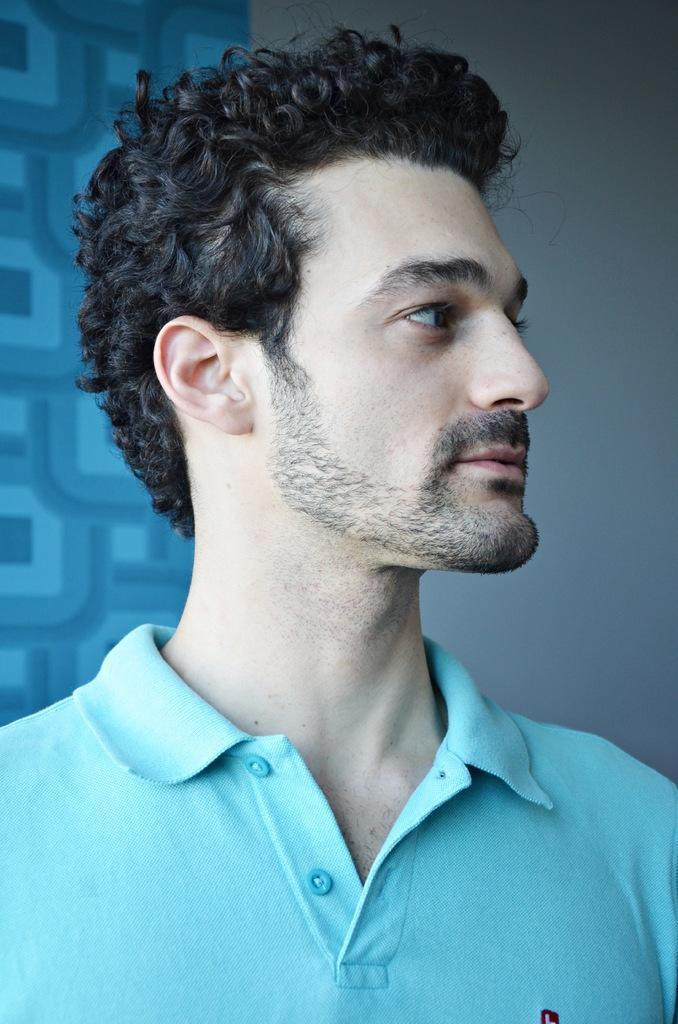Describe this image in one or two sentences. There is a man looking right side and wore blue t shirt. Background we can see wall. 